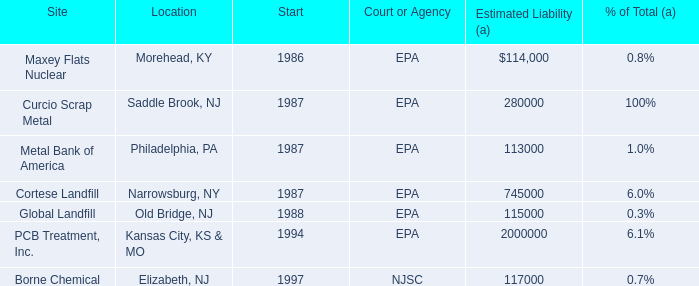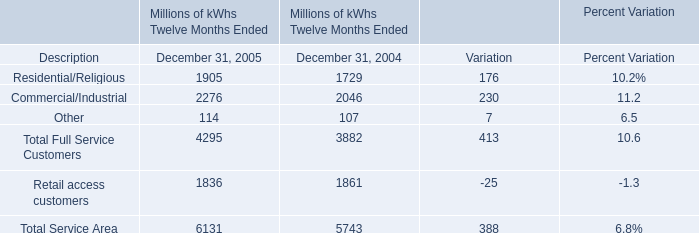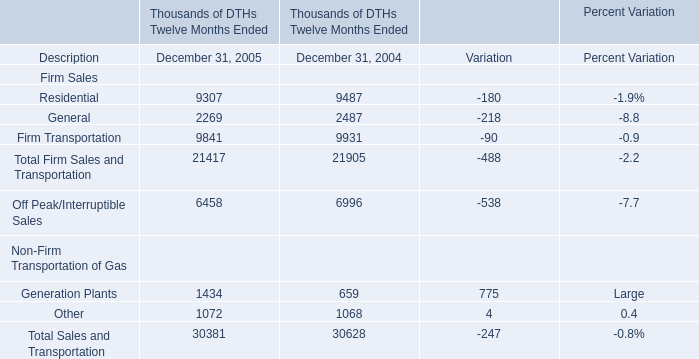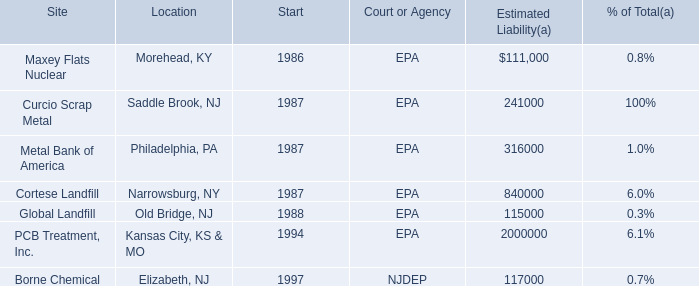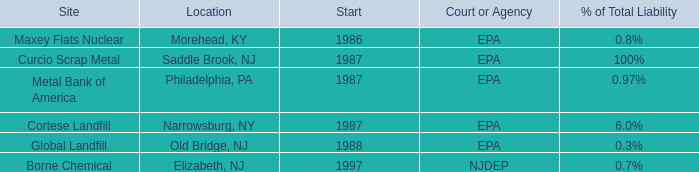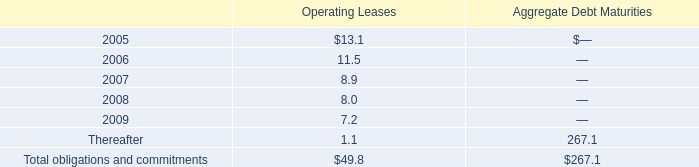What is the growing rate of Other in the year with the least Retail access customers? 
Computations: ((114 - 107) / 107)
Answer: 0.06542. 